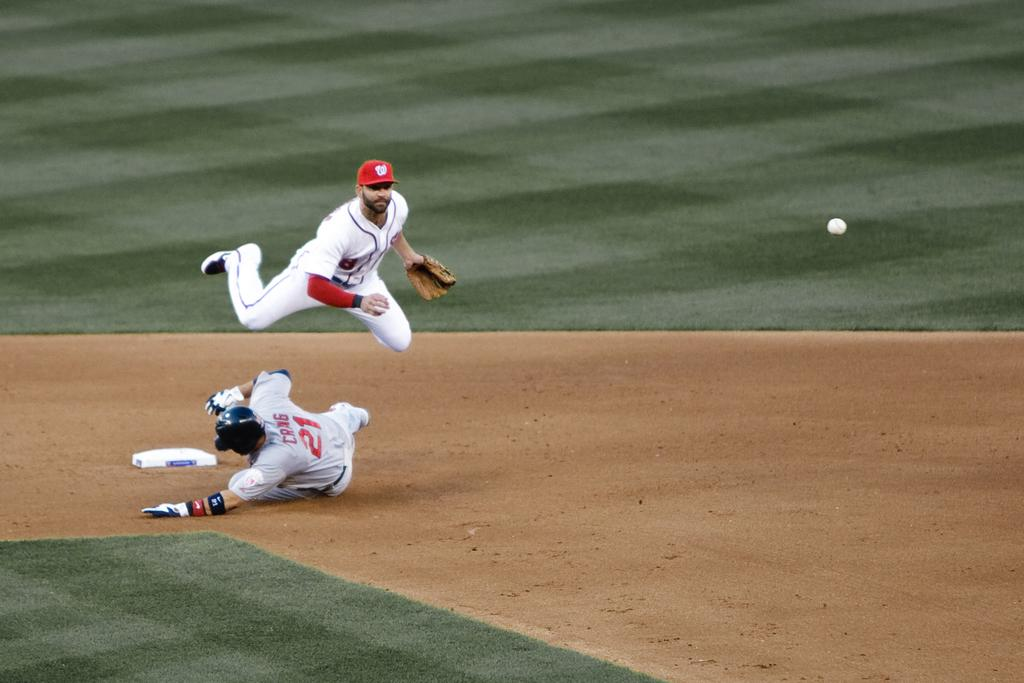<image>
Provide a brief description of the given image. Baseball player number 21 slides into second base while the second baseman tries to catch a ball to record an out. 